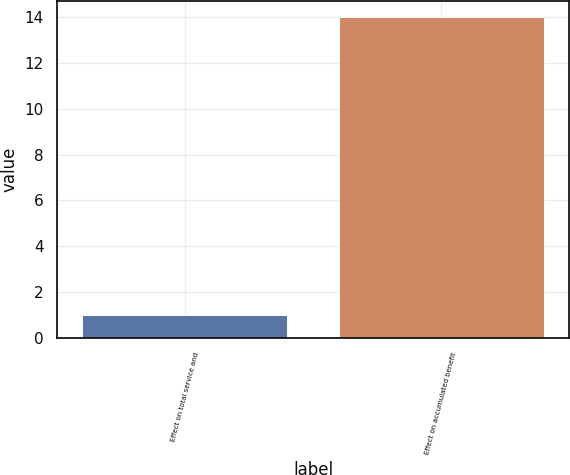Convert chart. <chart><loc_0><loc_0><loc_500><loc_500><bar_chart><fcel>Effect on total service and<fcel>Effect on accumulated benefit<nl><fcel>1<fcel>14<nl></chart> 